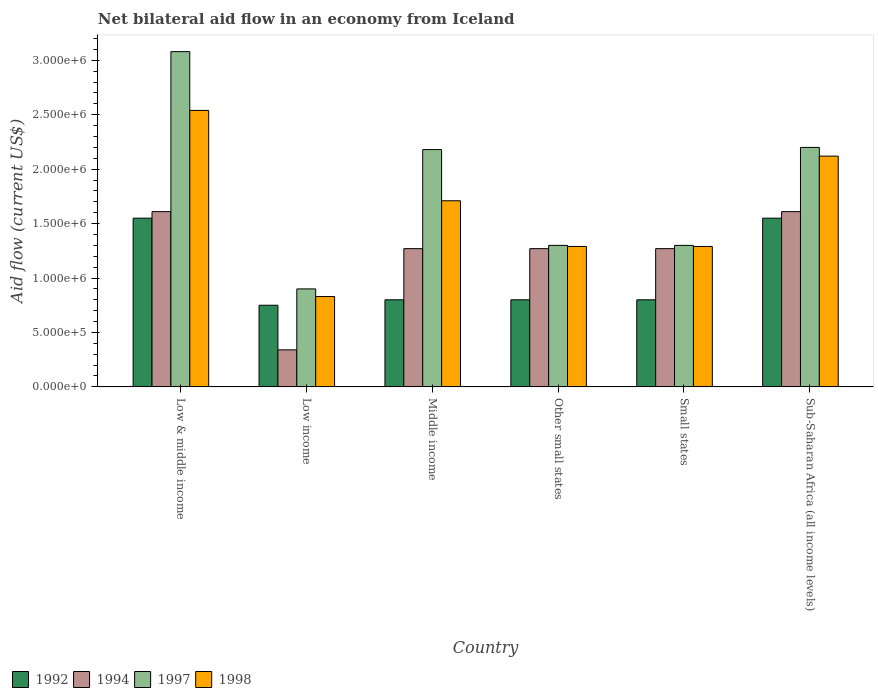How many different coloured bars are there?
Your answer should be very brief. 4. How many groups of bars are there?
Keep it short and to the point. 6. How many bars are there on the 5th tick from the left?
Your answer should be very brief. 4. What is the label of the 4th group of bars from the left?
Ensure brevity in your answer.  Other small states. In how many cases, is the number of bars for a given country not equal to the number of legend labels?
Provide a succinct answer. 0. What is the net bilateral aid flow in 1994 in Low income?
Ensure brevity in your answer.  3.40e+05. Across all countries, what is the maximum net bilateral aid flow in 1994?
Make the answer very short. 1.61e+06. Across all countries, what is the minimum net bilateral aid flow in 1992?
Ensure brevity in your answer.  7.50e+05. In which country was the net bilateral aid flow in 1998 maximum?
Ensure brevity in your answer.  Low & middle income. In which country was the net bilateral aid flow in 1998 minimum?
Offer a very short reply. Low income. What is the total net bilateral aid flow in 1997 in the graph?
Ensure brevity in your answer.  1.10e+07. What is the average net bilateral aid flow in 1998 per country?
Make the answer very short. 1.63e+06. In how many countries, is the net bilateral aid flow in 1992 greater than 200000 US$?
Ensure brevity in your answer.  6. What is the difference between the highest and the second highest net bilateral aid flow in 1992?
Keep it short and to the point. 7.50e+05. What is the difference between the highest and the lowest net bilateral aid flow in 1998?
Make the answer very short. 1.71e+06. In how many countries, is the net bilateral aid flow in 1992 greater than the average net bilateral aid flow in 1992 taken over all countries?
Provide a succinct answer. 2. Is the sum of the net bilateral aid flow in 1998 in Other small states and Sub-Saharan Africa (all income levels) greater than the maximum net bilateral aid flow in 1997 across all countries?
Your response must be concise. Yes. Is it the case that in every country, the sum of the net bilateral aid flow in 1992 and net bilateral aid flow in 1994 is greater than the sum of net bilateral aid flow in 1997 and net bilateral aid flow in 1998?
Ensure brevity in your answer.  No. What does the 3rd bar from the left in Small states represents?
Your answer should be very brief. 1997. Is it the case that in every country, the sum of the net bilateral aid flow in 1997 and net bilateral aid flow in 1992 is greater than the net bilateral aid flow in 1994?
Your answer should be compact. Yes. Are all the bars in the graph horizontal?
Provide a short and direct response. No. Does the graph contain grids?
Provide a short and direct response. No. How are the legend labels stacked?
Your answer should be compact. Horizontal. What is the title of the graph?
Give a very brief answer. Net bilateral aid flow in an economy from Iceland. Does "1979" appear as one of the legend labels in the graph?
Provide a succinct answer. No. What is the label or title of the X-axis?
Keep it short and to the point. Country. What is the label or title of the Y-axis?
Ensure brevity in your answer.  Aid flow (current US$). What is the Aid flow (current US$) of 1992 in Low & middle income?
Provide a succinct answer. 1.55e+06. What is the Aid flow (current US$) in 1994 in Low & middle income?
Make the answer very short. 1.61e+06. What is the Aid flow (current US$) of 1997 in Low & middle income?
Make the answer very short. 3.08e+06. What is the Aid flow (current US$) of 1998 in Low & middle income?
Your answer should be compact. 2.54e+06. What is the Aid flow (current US$) in 1992 in Low income?
Provide a succinct answer. 7.50e+05. What is the Aid flow (current US$) in 1994 in Low income?
Offer a very short reply. 3.40e+05. What is the Aid flow (current US$) of 1998 in Low income?
Provide a succinct answer. 8.30e+05. What is the Aid flow (current US$) of 1994 in Middle income?
Provide a succinct answer. 1.27e+06. What is the Aid flow (current US$) of 1997 in Middle income?
Ensure brevity in your answer.  2.18e+06. What is the Aid flow (current US$) in 1998 in Middle income?
Provide a short and direct response. 1.71e+06. What is the Aid flow (current US$) of 1992 in Other small states?
Offer a very short reply. 8.00e+05. What is the Aid flow (current US$) in 1994 in Other small states?
Ensure brevity in your answer.  1.27e+06. What is the Aid flow (current US$) in 1997 in Other small states?
Your answer should be compact. 1.30e+06. What is the Aid flow (current US$) in 1998 in Other small states?
Your answer should be very brief. 1.29e+06. What is the Aid flow (current US$) of 1992 in Small states?
Give a very brief answer. 8.00e+05. What is the Aid flow (current US$) in 1994 in Small states?
Provide a succinct answer. 1.27e+06. What is the Aid flow (current US$) in 1997 in Small states?
Provide a succinct answer. 1.30e+06. What is the Aid flow (current US$) of 1998 in Small states?
Offer a terse response. 1.29e+06. What is the Aid flow (current US$) of 1992 in Sub-Saharan Africa (all income levels)?
Your answer should be very brief. 1.55e+06. What is the Aid flow (current US$) in 1994 in Sub-Saharan Africa (all income levels)?
Offer a very short reply. 1.61e+06. What is the Aid flow (current US$) of 1997 in Sub-Saharan Africa (all income levels)?
Your answer should be compact. 2.20e+06. What is the Aid flow (current US$) in 1998 in Sub-Saharan Africa (all income levels)?
Ensure brevity in your answer.  2.12e+06. Across all countries, what is the maximum Aid flow (current US$) in 1992?
Your answer should be compact. 1.55e+06. Across all countries, what is the maximum Aid flow (current US$) of 1994?
Provide a short and direct response. 1.61e+06. Across all countries, what is the maximum Aid flow (current US$) in 1997?
Offer a very short reply. 3.08e+06. Across all countries, what is the maximum Aid flow (current US$) of 1998?
Provide a short and direct response. 2.54e+06. Across all countries, what is the minimum Aid flow (current US$) of 1992?
Your answer should be compact. 7.50e+05. Across all countries, what is the minimum Aid flow (current US$) of 1994?
Offer a terse response. 3.40e+05. Across all countries, what is the minimum Aid flow (current US$) of 1998?
Your response must be concise. 8.30e+05. What is the total Aid flow (current US$) of 1992 in the graph?
Offer a terse response. 6.25e+06. What is the total Aid flow (current US$) in 1994 in the graph?
Your answer should be compact. 7.37e+06. What is the total Aid flow (current US$) of 1997 in the graph?
Provide a short and direct response. 1.10e+07. What is the total Aid flow (current US$) in 1998 in the graph?
Your response must be concise. 9.78e+06. What is the difference between the Aid flow (current US$) in 1992 in Low & middle income and that in Low income?
Provide a succinct answer. 8.00e+05. What is the difference between the Aid flow (current US$) in 1994 in Low & middle income and that in Low income?
Make the answer very short. 1.27e+06. What is the difference between the Aid flow (current US$) of 1997 in Low & middle income and that in Low income?
Ensure brevity in your answer.  2.18e+06. What is the difference between the Aid flow (current US$) of 1998 in Low & middle income and that in Low income?
Your response must be concise. 1.71e+06. What is the difference between the Aid flow (current US$) of 1992 in Low & middle income and that in Middle income?
Your response must be concise. 7.50e+05. What is the difference between the Aid flow (current US$) of 1994 in Low & middle income and that in Middle income?
Your response must be concise. 3.40e+05. What is the difference between the Aid flow (current US$) in 1998 in Low & middle income and that in Middle income?
Offer a very short reply. 8.30e+05. What is the difference between the Aid flow (current US$) in 1992 in Low & middle income and that in Other small states?
Your answer should be compact. 7.50e+05. What is the difference between the Aid flow (current US$) of 1994 in Low & middle income and that in Other small states?
Ensure brevity in your answer.  3.40e+05. What is the difference between the Aid flow (current US$) in 1997 in Low & middle income and that in Other small states?
Your response must be concise. 1.78e+06. What is the difference between the Aid flow (current US$) of 1998 in Low & middle income and that in Other small states?
Your answer should be compact. 1.25e+06. What is the difference between the Aid flow (current US$) of 1992 in Low & middle income and that in Small states?
Make the answer very short. 7.50e+05. What is the difference between the Aid flow (current US$) of 1997 in Low & middle income and that in Small states?
Your answer should be compact. 1.78e+06. What is the difference between the Aid flow (current US$) in 1998 in Low & middle income and that in Small states?
Your answer should be very brief. 1.25e+06. What is the difference between the Aid flow (current US$) of 1992 in Low & middle income and that in Sub-Saharan Africa (all income levels)?
Keep it short and to the point. 0. What is the difference between the Aid flow (current US$) in 1997 in Low & middle income and that in Sub-Saharan Africa (all income levels)?
Your answer should be very brief. 8.80e+05. What is the difference between the Aid flow (current US$) of 1998 in Low & middle income and that in Sub-Saharan Africa (all income levels)?
Provide a short and direct response. 4.20e+05. What is the difference between the Aid flow (current US$) of 1992 in Low income and that in Middle income?
Your response must be concise. -5.00e+04. What is the difference between the Aid flow (current US$) of 1994 in Low income and that in Middle income?
Provide a short and direct response. -9.30e+05. What is the difference between the Aid flow (current US$) of 1997 in Low income and that in Middle income?
Your answer should be very brief. -1.28e+06. What is the difference between the Aid flow (current US$) of 1998 in Low income and that in Middle income?
Keep it short and to the point. -8.80e+05. What is the difference between the Aid flow (current US$) in 1994 in Low income and that in Other small states?
Offer a terse response. -9.30e+05. What is the difference between the Aid flow (current US$) in 1997 in Low income and that in Other small states?
Offer a terse response. -4.00e+05. What is the difference between the Aid flow (current US$) of 1998 in Low income and that in Other small states?
Offer a terse response. -4.60e+05. What is the difference between the Aid flow (current US$) of 1994 in Low income and that in Small states?
Provide a succinct answer. -9.30e+05. What is the difference between the Aid flow (current US$) of 1997 in Low income and that in Small states?
Offer a terse response. -4.00e+05. What is the difference between the Aid flow (current US$) of 1998 in Low income and that in Small states?
Offer a terse response. -4.60e+05. What is the difference between the Aid flow (current US$) of 1992 in Low income and that in Sub-Saharan Africa (all income levels)?
Make the answer very short. -8.00e+05. What is the difference between the Aid flow (current US$) of 1994 in Low income and that in Sub-Saharan Africa (all income levels)?
Offer a terse response. -1.27e+06. What is the difference between the Aid flow (current US$) in 1997 in Low income and that in Sub-Saharan Africa (all income levels)?
Your response must be concise. -1.30e+06. What is the difference between the Aid flow (current US$) of 1998 in Low income and that in Sub-Saharan Africa (all income levels)?
Keep it short and to the point. -1.29e+06. What is the difference between the Aid flow (current US$) in 1994 in Middle income and that in Other small states?
Offer a very short reply. 0. What is the difference between the Aid flow (current US$) in 1997 in Middle income and that in Other small states?
Your answer should be compact. 8.80e+05. What is the difference between the Aid flow (current US$) of 1992 in Middle income and that in Small states?
Your response must be concise. 0. What is the difference between the Aid flow (current US$) of 1994 in Middle income and that in Small states?
Provide a succinct answer. 0. What is the difference between the Aid flow (current US$) of 1997 in Middle income and that in Small states?
Provide a succinct answer. 8.80e+05. What is the difference between the Aid flow (current US$) of 1998 in Middle income and that in Small states?
Ensure brevity in your answer.  4.20e+05. What is the difference between the Aid flow (current US$) in 1992 in Middle income and that in Sub-Saharan Africa (all income levels)?
Your answer should be compact. -7.50e+05. What is the difference between the Aid flow (current US$) of 1994 in Middle income and that in Sub-Saharan Africa (all income levels)?
Provide a short and direct response. -3.40e+05. What is the difference between the Aid flow (current US$) of 1998 in Middle income and that in Sub-Saharan Africa (all income levels)?
Your answer should be compact. -4.10e+05. What is the difference between the Aid flow (current US$) in 1994 in Other small states and that in Small states?
Make the answer very short. 0. What is the difference between the Aid flow (current US$) of 1998 in Other small states and that in Small states?
Provide a succinct answer. 0. What is the difference between the Aid flow (current US$) in 1992 in Other small states and that in Sub-Saharan Africa (all income levels)?
Provide a short and direct response. -7.50e+05. What is the difference between the Aid flow (current US$) in 1994 in Other small states and that in Sub-Saharan Africa (all income levels)?
Your response must be concise. -3.40e+05. What is the difference between the Aid flow (current US$) in 1997 in Other small states and that in Sub-Saharan Africa (all income levels)?
Keep it short and to the point. -9.00e+05. What is the difference between the Aid flow (current US$) of 1998 in Other small states and that in Sub-Saharan Africa (all income levels)?
Your answer should be compact. -8.30e+05. What is the difference between the Aid flow (current US$) of 1992 in Small states and that in Sub-Saharan Africa (all income levels)?
Offer a very short reply. -7.50e+05. What is the difference between the Aid flow (current US$) in 1994 in Small states and that in Sub-Saharan Africa (all income levels)?
Offer a terse response. -3.40e+05. What is the difference between the Aid flow (current US$) of 1997 in Small states and that in Sub-Saharan Africa (all income levels)?
Give a very brief answer. -9.00e+05. What is the difference between the Aid flow (current US$) in 1998 in Small states and that in Sub-Saharan Africa (all income levels)?
Give a very brief answer. -8.30e+05. What is the difference between the Aid flow (current US$) of 1992 in Low & middle income and the Aid flow (current US$) of 1994 in Low income?
Provide a succinct answer. 1.21e+06. What is the difference between the Aid flow (current US$) of 1992 in Low & middle income and the Aid flow (current US$) of 1997 in Low income?
Provide a succinct answer. 6.50e+05. What is the difference between the Aid flow (current US$) of 1992 in Low & middle income and the Aid flow (current US$) of 1998 in Low income?
Provide a succinct answer. 7.20e+05. What is the difference between the Aid flow (current US$) in 1994 in Low & middle income and the Aid flow (current US$) in 1997 in Low income?
Your answer should be very brief. 7.10e+05. What is the difference between the Aid flow (current US$) of 1994 in Low & middle income and the Aid flow (current US$) of 1998 in Low income?
Give a very brief answer. 7.80e+05. What is the difference between the Aid flow (current US$) of 1997 in Low & middle income and the Aid flow (current US$) of 1998 in Low income?
Your answer should be very brief. 2.25e+06. What is the difference between the Aid flow (current US$) of 1992 in Low & middle income and the Aid flow (current US$) of 1997 in Middle income?
Ensure brevity in your answer.  -6.30e+05. What is the difference between the Aid flow (current US$) of 1994 in Low & middle income and the Aid flow (current US$) of 1997 in Middle income?
Your answer should be very brief. -5.70e+05. What is the difference between the Aid flow (current US$) of 1994 in Low & middle income and the Aid flow (current US$) of 1998 in Middle income?
Offer a terse response. -1.00e+05. What is the difference between the Aid flow (current US$) in 1997 in Low & middle income and the Aid flow (current US$) in 1998 in Middle income?
Provide a succinct answer. 1.37e+06. What is the difference between the Aid flow (current US$) of 1992 in Low & middle income and the Aid flow (current US$) of 1997 in Other small states?
Your response must be concise. 2.50e+05. What is the difference between the Aid flow (current US$) in 1992 in Low & middle income and the Aid flow (current US$) in 1998 in Other small states?
Provide a short and direct response. 2.60e+05. What is the difference between the Aid flow (current US$) in 1994 in Low & middle income and the Aid flow (current US$) in 1997 in Other small states?
Your answer should be compact. 3.10e+05. What is the difference between the Aid flow (current US$) in 1997 in Low & middle income and the Aid flow (current US$) in 1998 in Other small states?
Offer a very short reply. 1.79e+06. What is the difference between the Aid flow (current US$) of 1992 in Low & middle income and the Aid flow (current US$) of 1994 in Small states?
Your response must be concise. 2.80e+05. What is the difference between the Aid flow (current US$) of 1994 in Low & middle income and the Aid flow (current US$) of 1997 in Small states?
Provide a succinct answer. 3.10e+05. What is the difference between the Aid flow (current US$) in 1997 in Low & middle income and the Aid flow (current US$) in 1998 in Small states?
Provide a short and direct response. 1.79e+06. What is the difference between the Aid flow (current US$) in 1992 in Low & middle income and the Aid flow (current US$) in 1997 in Sub-Saharan Africa (all income levels)?
Your answer should be very brief. -6.50e+05. What is the difference between the Aid flow (current US$) in 1992 in Low & middle income and the Aid flow (current US$) in 1998 in Sub-Saharan Africa (all income levels)?
Provide a short and direct response. -5.70e+05. What is the difference between the Aid flow (current US$) in 1994 in Low & middle income and the Aid flow (current US$) in 1997 in Sub-Saharan Africa (all income levels)?
Provide a succinct answer. -5.90e+05. What is the difference between the Aid flow (current US$) in 1994 in Low & middle income and the Aid flow (current US$) in 1998 in Sub-Saharan Africa (all income levels)?
Your answer should be compact. -5.10e+05. What is the difference between the Aid flow (current US$) of 1997 in Low & middle income and the Aid flow (current US$) of 1998 in Sub-Saharan Africa (all income levels)?
Offer a very short reply. 9.60e+05. What is the difference between the Aid flow (current US$) in 1992 in Low income and the Aid flow (current US$) in 1994 in Middle income?
Offer a terse response. -5.20e+05. What is the difference between the Aid flow (current US$) in 1992 in Low income and the Aid flow (current US$) in 1997 in Middle income?
Your response must be concise. -1.43e+06. What is the difference between the Aid flow (current US$) in 1992 in Low income and the Aid flow (current US$) in 1998 in Middle income?
Your answer should be compact. -9.60e+05. What is the difference between the Aid flow (current US$) in 1994 in Low income and the Aid flow (current US$) in 1997 in Middle income?
Your answer should be very brief. -1.84e+06. What is the difference between the Aid flow (current US$) of 1994 in Low income and the Aid flow (current US$) of 1998 in Middle income?
Your response must be concise. -1.37e+06. What is the difference between the Aid flow (current US$) of 1997 in Low income and the Aid flow (current US$) of 1998 in Middle income?
Offer a terse response. -8.10e+05. What is the difference between the Aid flow (current US$) of 1992 in Low income and the Aid flow (current US$) of 1994 in Other small states?
Make the answer very short. -5.20e+05. What is the difference between the Aid flow (current US$) of 1992 in Low income and the Aid flow (current US$) of 1997 in Other small states?
Give a very brief answer. -5.50e+05. What is the difference between the Aid flow (current US$) in 1992 in Low income and the Aid flow (current US$) in 1998 in Other small states?
Offer a terse response. -5.40e+05. What is the difference between the Aid flow (current US$) of 1994 in Low income and the Aid flow (current US$) of 1997 in Other small states?
Offer a terse response. -9.60e+05. What is the difference between the Aid flow (current US$) in 1994 in Low income and the Aid flow (current US$) in 1998 in Other small states?
Your answer should be compact. -9.50e+05. What is the difference between the Aid flow (current US$) in 1997 in Low income and the Aid flow (current US$) in 1998 in Other small states?
Ensure brevity in your answer.  -3.90e+05. What is the difference between the Aid flow (current US$) in 1992 in Low income and the Aid flow (current US$) in 1994 in Small states?
Your answer should be very brief. -5.20e+05. What is the difference between the Aid flow (current US$) in 1992 in Low income and the Aid flow (current US$) in 1997 in Small states?
Offer a terse response. -5.50e+05. What is the difference between the Aid flow (current US$) in 1992 in Low income and the Aid flow (current US$) in 1998 in Small states?
Your answer should be very brief. -5.40e+05. What is the difference between the Aid flow (current US$) of 1994 in Low income and the Aid flow (current US$) of 1997 in Small states?
Offer a very short reply. -9.60e+05. What is the difference between the Aid flow (current US$) of 1994 in Low income and the Aid flow (current US$) of 1998 in Small states?
Give a very brief answer. -9.50e+05. What is the difference between the Aid flow (current US$) in 1997 in Low income and the Aid flow (current US$) in 1998 in Small states?
Offer a terse response. -3.90e+05. What is the difference between the Aid flow (current US$) of 1992 in Low income and the Aid flow (current US$) of 1994 in Sub-Saharan Africa (all income levels)?
Ensure brevity in your answer.  -8.60e+05. What is the difference between the Aid flow (current US$) of 1992 in Low income and the Aid flow (current US$) of 1997 in Sub-Saharan Africa (all income levels)?
Provide a short and direct response. -1.45e+06. What is the difference between the Aid flow (current US$) in 1992 in Low income and the Aid flow (current US$) in 1998 in Sub-Saharan Africa (all income levels)?
Make the answer very short. -1.37e+06. What is the difference between the Aid flow (current US$) in 1994 in Low income and the Aid flow (current US$) in 1997 in Sub-Saharan Africa (all income levels)?
Offer a terse response. -1.86e+06. What is the difference between the Aid flow (current US$) in 1994 in Low income and the Aid flow (current US$) in 1998 in Sub-Saharan Africa (all income levels)?
Your response must be concise. -1.78e+06. What is the difference between the Aid flow (current US$) in 1997 in Low income and the Aid flow (current US$) in 1998 in Sub-Saharan Africa (all income levels)?
Provide a succinct answer. -1.22e+06. What is the difference between the Aid flow (current US$) of 1992 in Middle income and the Aid flow (current US$) of 1994 in Other small states?
Make the answer very short. -4.70e+05. What is the difference between the Aid flow (current US$) of 1992 in Middle income and the Aid flow (current US$) of 1997 in Other small states?
Make the answer very short. -5.00e+05. What is the difference between the Aid flow (current US$) in 1992 in Middle income and the Aid flow (current US$) in 1998 in Other small states?
Provide a short and direct response. -4.90e+05. What is the difference between the Aid flow (current US$) in 1994 in Middle income and the Aid flow (current US$) in 1997 in Other small states?
Your answer should be compact. -3.00e+04. What is the difference between the Aid flow (current US$) of 1997 in Middle income and the Aid flow (current US$) of 1998 in Other small states?
Offer a very short reply. 8.90e+05. What is the difference between the Aid flow (current US$) of 1992 in Middle income and the Aid flow (current US$) of 1994 in Small states?
Your answer should be very brief. -4.70e+05. What is the difference between the Aid flow (current US$) of 1992 in Middle income and the Aid flow (current US$) of 1997 in Small states?
Offer a very short reply. -5.00e+05. What is the difference between the Aid flow (current US$) of 1992 in Middle income and the Aid flow (current US$) of 1998 in Small states?
Offer a very short reply. -4.90e+05. What is the difference between the Aid flow (current US$) in 1997 in Middle income and the Aid flow (current US$) in 1998 in Small states?
Provide a succinct answer. 8.90e+05. What is the difference between the Aid flow (current US$) in 1992 in Middle income and the Aid flow (current US$) in 1994 in Sub-Saharan Africa (all income levels)?
Offer a very short reply. -8.10e+05. What is the difference between the Aid flow (current US$) in 1992 in Middle income and the Aid flow (current US$) in 1997 in Sub-Saharan Africa (all income levels)?
Offer a terse response. -1.40e+06. What is the difference between the Aid flow (current US$) in 1992 in Middle income and the Aid flow (current US$) in 1998 in Sub-Saharan Africa (all income levels)?
Make the answer very short. -1.32e+06. What is the difference between the Aid flow (current US$) in 1994 in Middle income and the Aid flow (current US$) in 1997 in Sub-Saharan Africa (all income levels)?
Make the answer very short. -9.30e+05. What is the difference between the Aid flow (current US$) of 1994 in Middle income and the Aid flow (current US$) of 1998 in Sub-Saharan Africa (all income levels)?
Offer a very short reply. -8.50e+05. What is the difference between the Aid flow (current US$) of 1992 in Other small states and the Aid flow (current US$) of 1994 in Small states?
Provide a short and direct response. -4.70e+05. What is the difference between the Aid flow (current US$) in 1992 in Other small states and the Aid flow (current US$) in 1997 in Small states?
Your answer should be compact. -5.00e+05. What is the difference between the Aid flow (current US$) in 1992 in Other small states and the Aid flow (current US$) in 1998 in Small states?
Offer a terse response. -4.90e+05. What is the difference between the Aid flow (current US$) of 1994 in Other small states and the Aid flow (current US$) of 1998 in Small states?
Offer a terse response. -2.00e+04. What is the difference between the Aid flow (current US$) in 1997 in Other small states and the Aid flow (current US$) in 1998 in Small states?
Keep it short and to the point. 10000. What is the difference between the Aid flow (current US$) in 1992 in Other small states and the Aid flow (current US$) in 1994 in Sub-Saharan Africa (all income levels)?
Your answer should be compact. -8.10e+05. What is the difference between the Aid flow (current US$) in 1992 in Other small states and the Aid flow (current US$) in 1997 in Sub-Saharan Africa (all income levels)?
Give a very brief answer. -1.40e+06. What is the difference between the Aid flow (current US$) of 1992 in Other small states and the Aid flow (current US$) of 1998 in Sub-Saharan Africa (all income levels)?
Provide a short and direct response. -1.32e+06. What is the difference between the Aid flow (current US$) of 1994 in Other small states and the Aid flow (current US$) of 1997 in Sub-Saharan Africa (all income levels)?
Provide a succinct answer. -9.30e+05. What is the difference between the Aid flow (current US$) of 1994 in Other small states and the Aid flow (current US$) of 1998 in Sub-Saharan Africa (all income levels)?
Your response must be concise. -8.50e+05. What is the difference between the Aid flow (current US$) in 1997 in Other small states and the Aid flow (current US$) in 1998 in Sub-Saharan Africa (all income levels)?
Keep it short and to the point. -8.20e+05. What is the difference between the Aid flow (current US$) in 1992 in Small states and the Aid flow (current US$) in 1994 in Sub-Saharan Africa (all income levels)?
Your response must be concise. -8.10e+05. What is the difference between the Aid flow (current US$) in 1992 in Small states and the Aid flow (current US$) in 1997 in Sub-Saharan Africa (all income levels)?
Provide a short and direct response. -1.40e+06. What is the difference between the Aid flow (current US$) of 1992 in Small states and the Aid flow (current US$) of 1998 in Sub-Saharan Africa (all income levels)?
Give a very brief answer. -1.32e+06. What is the difference between the Aid flow (current US$) in 1994 in Small states and the Aid flow (current US$) in 1997 in Sub-Saharan Africa (all income levels)?
Keep it short and to the point. -9.30e+05. What is the difference between the Aid flow (current US$) of 1994 in Small states and the Aid flow (current US$) of 1998 in Sub-Saharan Africa (all income levels)?
Make the answer very short. -8.50e+05. What is the difference between the Aid flow (current US$) in 1997 in Small states and the Aid flow (current US$) in 1998 in Sub-Saharan Africa (all income levels)?
Provide a succinct answer. -8.20e+05. What is the average Aid flow (current US$) of 1992 per country?
Make the answer very short. 1.04e+06. What is the average Aid flow (current US$) of 1994 per country?
Make the answer very short. 1.23e+06. What is the average Aid flow (current US$) of 1997 per country?
Offer a very short reply. 1.83e+06. What is the average Aid flow (current US$) of 1998 per country?
Give a very brief answer. 1.63e+06. What is the difference between the Aid flow (current US$) of 1992 and Aid flow (current US$) of 1994 in Low & middle income?
Your response must be concise. -6.00e+04. What is the difference between the Aid flow (current US$) in 1992 and Aid flow (current US$) in 1997 in Low & middle income?
Your answer should be compact. -1.53e+06. What is the difference between the Aid flow (current US$) of 1992 and Aid flow (current US$) of 1998 in Low & middle income?
Give a very brief answer. -9.90e+05. What is the difference between the Aid flow (current US$) in 1994 and Aid flow (current US$) in 1997 in Low & middle income?
Ensure brevity in your answer.  -1.47e+06. What is the difference between the Aid flow (current US$) of 1994 and Aid flow (current US$) of 1998 in Low & middle income?
Your response must be concise. -9.30e+05. What is the difference between the Aid flow (current US$) of 1997 and Aid flow (current US$) of 1998 in Low & middle income?
Make the answer very short. 5.40e+05. What is the difference between the Aid flow (current US$) in 1992 and Aid flow (current US$) in 1997 in Low income?
Make the answer very short. -1.50e+05. What is the difference between the Aid flow (current US$) of 1994 and Aid flow (current US$) of 1997 in Low income?
Give a very brief answer. -5.60e+05. What is the difference between the Aid flow (current US$) in 1994 and Aid flow (current US$) in 1998 in Low income?
Your answer should be very brief. -4.90e+05. What is the difference between the Aid flow (current US$) of 1997 and Aid flow (current US$) of 1998 in Low income?
Your answer should be very brief. 7.00e+04. What is the difference between the Aid flow (current US$) of 1992 and Aid flow (current US$) of 1994 in Middle income?
Give a very brief answer. -4.70e+05. What is the difference between the Aid flow (current US$) of 1992 and Aid flow (current US$) of 1997 in Middle income?
Your answer should be compact. -1.38e+06. What is the difference between the Aid flow (current US$) in 1992 and Aid flow (current US$) in 1998 in Middle income?
Provide a short and direct response. -9.10e+05. What is the difference between the Aid flow (current US$) in 1994 and Aid flow (current US$) in 1997 in Middle income?
Offer a very short reply. -9.10e+05. What is the difference between the Aid flow (current US$) of 1994 and Aid flow (current US$) of 1998 in Middle income?
Ensure brevity in your answer.  -4.40e+05. What is the difference between the Aid flow (current US$) of 1992 and Aid flow (current US$) of 1994 in Other small states?
Your response must be concise. -4.70e+05. What is the difference between the Aid flow (current US$) in 1992 and Aid flow (current US$) in 1997 in Other small states?
Your answer should be very brief. -5.00e+05. What is the difference between the Aid flow (current US$) in 1992 and Aid flow (current US$) in 1998 in Other small states?
Make the answer very short. -4.90e+05. What is the difference between the Aid flow (current US$) of 1997 and Aid flow (current US$) of 1998 in Other small states?
Your answer should be very brief. 10000. What is the difference between the Aid flow (current US$) of 1992 and Aid flow (current US$) of 1994 in Small states?
Offer a terse response. -4.70e+05. What is the difference between the Aid flow (current US$) in 1992 and Aid flow (current US$) in 1997 in Small states?
Your answer should be compact. -5.00e+05. What is the difference between the Aid flow (current US$) of 1992 and Aid flow (current US$) of 1998 in Small states?
Give a very brief answer. -4.90e+05. What is the difference between the Aid flow (current US$) in 1997 and Aid flow (current US$) in 1998 in Small states?
Give a very brief answer. 10000. What is the difference between the Aid flow (current US$) in 1992 and Aid flow (current US$) in 1994 in Sub-Saharan Africa (all income levels)?
Make the answer very short. -6.00e+04. What is the difference between the Aid flow (current US$) of 1992 and Aid flow (current US$) of 1997 in Sub-Saharan Africa (all income levels)?
Offer a very short reply. -6.50e+05. What is the difference between the Aid flow (current US$) of 1992 and Aid flow (current US$) of 1998 in Sub-Saharan Africa (all income levels)?
Give a very brief answer. -5.70e+05. What is the difference between the Aid flow (current US$) in 1994 and Aid flow (current US$) in 1997 in Sub-Saharan Africa (all income levels)?
Ensure brevity in your answer.  -5.90e+05. What is the difference between the Aid flow (current US$) of 1994 and Aid flow (current US$) of 1998 in Sub-Saharan Africa (all income levels)?
Offer a terse response. -5.10e+05. What is the difference between the Aid flow (current US$) of 1997 and Aid flow (current US$) of 1998 in Sub-Saharan Africa (all income levels)?
Keep it short and to the point. 8.00e+04. What is the ratio of the Aid flow (current US$) in 1992 in Low & middle income to that in Low income?
Provide a succinct answer. 2.07. What is the ratio of the Aid flow (current US$) in 1994 in Low & middle income to that in Low income?
Provide a short and direct response. 4.74. What is the ratio of the Aid flow (current US$) in 1997 in Low & middle income to that in Low income?
Offer a terse response. 3.42. What is the ratio of the Aid flow (current US$) of 1998 in Low & middle income to that in Low income?
Your response must be concise. 3.06. What is the ratio of the Aid flow (current US$) in 1992 in Low & middle income to that in Middle income?
Ensure brevity in your answer.  1.94. What is the ratio of the Aid flow (current US$) of 1994 in Low & middle income to that in Middle income?
Provide a succinct answer. 1.27. What is the ratio of the Aid flow (current US$) in 1997 in Low & middle income to that in Middle income?
Ensure brevity in your answer.  1.41. What is the ratio of the Aid flow (current US$) of 1998 in Low & middle income to that in Middle income?
Your response must be concise. 1.49. What is the ratio of the Aid flow (current US$) in 1992 in Low & middle income to that in Other small states?
Keep it short and to the point. 1.94. What is the ratio of the Aid flow (current US$) in 1994 in Low & middle income to that in Other small states?
Your response must be concise. 1.27. What is the ratio of the Aid flow (current US$) of 1997 in Low & middle income to that in Other small states?
Make the answer very short. 2.37. What is the ratio of the Aid flow (current US$) in 1998 in Low & middle income to that in Other small states?
Your answer should be very brief. 1.97. What is the ratio of the Aid flow (current US$) of 1992 in Low & middle income to that in Small states?
Provide a short and direct response. 1.94. What is the ratio of the Aid flow (current US$) of 1994 in Low & middle income to that in Small states?
Offer a terse response. 1.27. What is the ratio of the Aid flow (current US$) in 1997 in Low & middle income to that in Small states?
Ensure brevity in your answer.  2.37. What is the ratio of the Aid flow (current US$) in 1998 in Low & middle income to that in Small states?
Keep it short and to the point. 1.97. What is the ratio of the Aid flow (current US$) of 1994 in Low & middle income to that in Sub-Saharan Africa (all income levels)?
Your answer should be compact. 1. What is the ratio of the Aid flow (current US$) in 1997 in Low & middle income to that in Sub-Saharan Africa (all income levels)?
Your response must be concise. 1.4. What is the ratio of the Aid flow (current US$) of 1998 in Low & middle income to that in Sub-Saharan Africa (all income levels)?
Ensure brevity in your answer.  1.2. What is the ratio of the Aid flow (current US$) of 1992 in Low income to that in Middle income?
Your answer should be compact. 0.94. What is the ratio of the Aid flow (current US$) of 1994 in Low income to that in Middle income?
Your answer should be very brief. 0.27. What is the ratio of the Aid flow (current US$) in 1997 in Low income to that in Middle income?
Your answer should be very brief. 0.41. What is the ratio of the Aid flow (current US$) in 1998 in Low income to that in Middle income?
Your answer should be compact. 0.49. What is the ratio of the Aid flow (current US$) in 1994 in Low income to that in Other small states?
Ensure brevity in your answer.  0.27. What is the ratio of the Aid flow (current US$) of 1997 in Low income to that in Other small states?
Give a very brief answer. 0.69. What is the ratio of the Aid flow (current US$) of 1998 in Low income to that in Other small states?
Give a very brief answer. 0.64. What is the ratio of the Aid flow (current US$) in 1994 in Low income to that in Small states?
Your response must be concise. 0.27. What is the ratio of the Aid flow (current US$) of 1997 in Low income to that in Small states?
Give a very brief answer. 0.69. What is the ratio of the Aid flow (current US$) in 1998 in Low income to that in Small states?
Give a very brief answer. 0.64. What is the ratio of the Aid flow (current US$) of 1992 in Low income to that in Sub-Saharan Africa (all income levels)?
Offer a terse response. 0.48. What is the ratio of the Aid flow (current US$) of 1994 in Low income to that in Sub-Saharan Africa (all income levels)?
Your answer should be compact. 0.21. What is the ratio of the Aid flow (current US$) of 1997 in Low income to that in Sub-Saharan Africa (all income levels)?
Offer a very short reply. 0.41. What is the ratio of the Aid flow (current US$) in 1998 in Low income to that in Sub-Saharan Africa (all income levels)?
Offer a terse response. 0.39. What is the ratio of the Aid flow (current US$) in 1992 in Middle income to that in Other small states?
Make the answer very short. 1. What is the ratio of the Aid flow (current US$) of 1997 in Middle income to that in Other small states?
Your response must be concise. 1.68. What is the ratio of the Aid flow (current US$) in 1998 in Middle income to that in Other small states?
Provide a short and direct response. 1.33. What is the ratio of the Aid flow (current US$) of 1994 in Middle income to that in Small states?
Your response must be concise. 1. What is the ratio of the Aid flow (current US$) of 1997 in Middle income to that in Small states?
Keep it short and to the point. 1.68. What is the ratio of the Aid flow (current US$) of 1998 in Middle income to that in Small states?
Provide a short and direct response. 1.33. What is the ratio of the Aid flow (current US$) of 1992 in Middle income to that in Sub-Saharan Africa (all income levels)?
Provide a short and direct response. 0.52. What is the ratio of the Aid flow (current US$) in 1994 in Middle income to that in Sub-Saharan Africa (all income levels)?
Give a very brief answer. 0.79. What is the ratio of the Aid flow (current US$) of 1997 in Middle income to that in Sub-Saharan Africa (all income levels)?
Offer a very short reply. 0.99. What is the ratio of the Aid flow (current US$) in 1998 in Middle income to that in Sub-Saharan Africa (all income levels)?
Ensure brevity in your answer.  0.81. What is the ratio of the Aid flow (current US$) in 1997 in Other small states to that in Small states?
Your answer should be very brief. 1. What is the ratio of the Aid flow (current US$) in 1998 in Other small states to that in Small states?
Your answer should be very brief. 1. What is the ratio of the Aid flow (current US$) of 1992 in Other small states to that in Sub-Saharan Africa (all income levels)?
Give a very brief answer. 0.52. What is the ratio of the Aid flow (current US$) in 1994 in Other small states to that in Sub-Saharan Africa (all income levels)?
Your response must be concise. 0.79. What is the ratio of the Aid flow (current US$) in 1997 in Other small states to that in Sub-Saharan Africa (all income levels)?
Offer a very short reply. 0.59. What is the ratio of the Aid flow (current US$) of 1998 in Other small states to that in Sub-Saharan Africa (all income levels)?
Ensure brevity in your answer.  0.61. What is the ratio of the Aid flow (current US$) in 1992 in Small states to that in Sub-Saharan Africa (all income levels)?
Your answer should be compact. 0.52. What is the ratio of the Aid flow (current US$) of 1994 in Small states to that in Sub-Saharan Africa (all income levels)?
Provide a short and direct response. 0.79. What is the ratio of the Aid flow (current US$) of 1997 in Small states to that in Sub-Saharan Africa (all income levels)?
Offer a terse response. 0.59. What is the ratio of the Aid flow (current US$) in 1998 in Small states to that in Sub-Saharan Africa (all income levels)?
Ensure brevity in your answer.  0.61. What is the difference between the highest and the second highest Aid flow (current US$) of 1994?
Your response must be concise. 0. What is the difference between the highest and the second highest Aid flow (current US$) in 1997?
Make the answer very short. 8.80e+05. What is the difference between the highest and the lowest Aid flow (current US$) in 1992?
Make the answer very short. 8.00e+05. What is the difference between the highest and the lowest Aid flow (current US$) in 1994?
Your answer should be compact. 1.27e+06. What is the difference between the highest and the lowest Aid flow (current US$) of 1997?
Make the answer very short. 2.18e+06. What is the difference between the highest and the lowest Aid flow (current US$) in 1998?
Keep it short and to the point. 1.71e+06. 